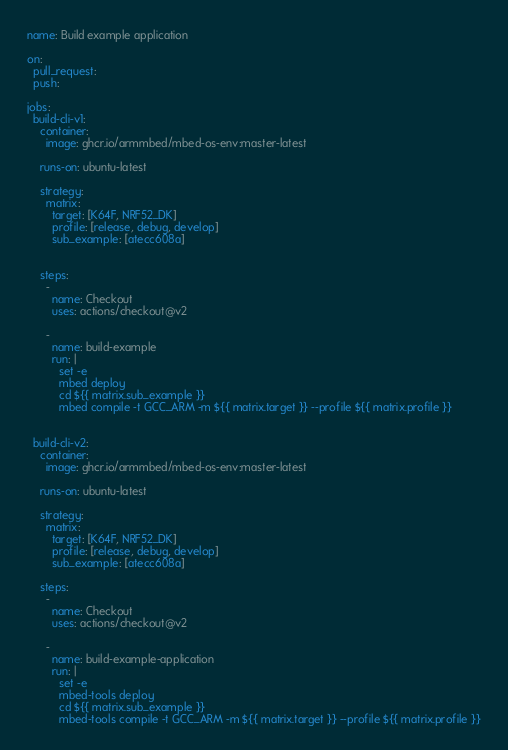<code> <loc_0><loc_0><loc_500><loc_500><_YAML_>name: Build example application

on:
  pull_request:
  push:

jobs: 
  build-cli-v1:
    container:
      image: ghcr.io/armmbed/mbed-os-env:master-latest

    runs-on: ubuntu-latest

    strategy:
      matrix:
        target: [K64F, NRF52_DK]
        profile: [release, debug, develop]
        sub_example: [atecc608a]  
        

    steps:
      -
        name: Checkout
        uses: actions/checkout@v2
          
      -
        name: build-example
        run: |
          set -e
          mbed deploy
          cd ${{ matrix.sub_example }}
          mbed compile -t GCC_ARM -m ${{ matrix.target }} --profile ${{ matrix.profile }}
          

  build-cli-v2:
    container:
      image: ghcr.io/armmbed/mbed-os-env:master-latest

    runs-on: ubuntu-latest

    strategy:
      matrix:
        target: [K64F, NRF52_DK]
        profile: [release, debug, develop]
        sub_example: [atecc608a]      

    steps:
      -
        name: Checkout
        uses: actions/checkout@v2
          
      -
        name: build-example-application
        run: |
          set -e
          mbed-tools deploy
          cd ${{ matrix.sub_example }}
          mbed-tools compile -t GCC_ARM -m ${{ matrix.target }} --profile ${{ matrix.profile }}
</code> 